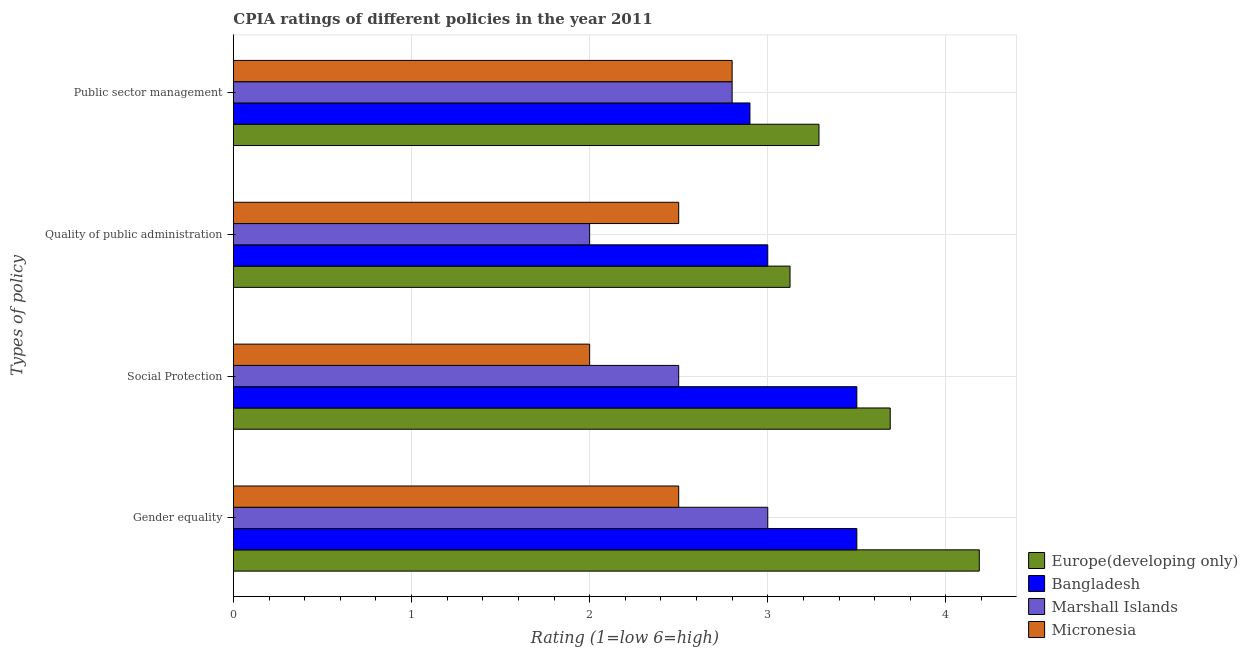Are the number of bars on each tick of the Y-axis equal?
Give a very brief answer. Yes. What is the label of the 2nd group of bars from the top?
Ensure brevity in your answer.  Quality of public administration. Across all countries, what is the maximum cpia rating of social protection?
Make the answer very short. 3.69. Across all countries, what is the minimum cpia rating of gender equality?
Your answer should be compact. 2.5. In which country was the cpia rating of quality of public administration maximum?
Your answer should be very brief. Europe(developing only). In which country was the cpia rating of social protection minimum?
Your answer should be very brief. Micronesia. What is the total cpia rating of quality of public administration in the graph?
Give a very brief answer. 10.62. What is the difference between the cpia rating of social protection in Europe(developing only) and that in Marshall Islands?
Give a very brief answer. 1.19. What is the difference between the cpia rating of social protection in Marshall Islands and the cpia rating of quality of public administration in Europe(developing only)?
Your response must be concise. -0.62. What is the average cpia rating of social protection per country?
Provide a succinct answer. 2.92. What is the difference between the cpia rating of social protection and cpia rating of quality of public administration in Europe(developing only)?
Provide a short and direct response. 0.56. In how many countries, is the cpia rating of social protection greater than 3 ?
Make the answer very short. 2. What is the ratio of the cpia rating of quality of public administration in Bangladesh to that in Europe(developing only)?
Ensure brevity in your answer.  0.96. Is the cpia rating of gender equality in Bangladesh less than that in Micronesia?
Provide a succinct answer. No. What is the difference between the highest and the second highest cpia rating of quality of public administration?
Give a very brief answer. 0.12. In how many countries, is the cpia rating of public sector management greater than the average cpia rating of public sector management taken over all countries?
Keep it short and to the point. 1. Is the sum of the cpia rating of gender equality in Marshall Islands and Micronesia greater than the maximum cpia rating of social protection across all countries?
Provide a succinct answer. Yes. Is it the case that in every country, the sum of the cpia rating of gender equality and cpia rating of social protection is greater than the sum of cpia rating of public sector management and cpia rating of quality of public administration?
Ensure brevity in your answer.  No. What does the 1st bar from the top in Quality of public administration represents?
Offer a very short reply. Micronesia. What does the 3rd bar from the bottom in Social Protection represents?
Make the answer very short. Marshall Islands. How many bars are there?
Provide a short and direct response. 16. How many countries are there in the graph?
Your response must be concise. 4. Are the values on the major ticks of X-axis written in scientific E-notation?
Your answer should be compact. No. Does the graph contain any zero values?
Your answer should be compact. No. Does the graph contain grids?
Make the answer very short. Yes. How are the legend labels stacked?
Offer a terse response. Vertical. What is the title of the graph?
Your answer should be very brief. CPIA ratings of different policies in the year 2011. What is the label or title of the X-axis?
Your response must be concise. Rating (1=low 6=high). What is the label or title of the Y-axis?
Provide a short and direct response. Types of policy. What is the Rating (1=low 6=high) of Europe(developing only) in Gender equality?
Your answer should be very brief. 4.19. What is the Rating (1=low 6=high) of Bangladesh in Gender equality?
Your answer should be very brief. 3.5. What is the Rating (1=low 6=high) in Marshall Islands in Gender equality?
Give a very brief answer. 3. What is the Rating (1=low 6=high) in Europe(developing only) in Social Protection?
Offer a terse response. 3.69. What is the Rating (1=low 6=high) of Bangladesh in Social Protection?
Offer a terse response. 3.5. What is the Rating (1=low 6=high) of Micronesia in Social Protection?
Offer a terse response. 2. What is the Rating (1=low 6=high) in Europe(developing only) in Quality of public administration?
Give a very brief answer. 3.12. What is the Rating (1=low 6=high) in Europe(developing only) in Public sector management?
Ensure brevity in your answer.  3.29. What is the Rating (1=low 6=high) of Bangladesh in Public sector management?
Offer a terse response. 2.9. Across all Types of policy, what is the maximum Rating (1=low 6=high) in Europe(developing only)?
Make the answer very short. 4.19. Across all Types of policy, what is the maximum Rating (1=low 6=high) of Marshall Islands?
Your answer should be compact. 3. Across all Types of policy, what is the minimum Rating (1=low 6=high) in Europe(developing only)?
Provide a succinct answer. 3.12. Across all Types of policy, what is the minimum Rating (1=low 6=high) in Micronesia?
Give a very brief answer. 2. What is the total Rating (1=low 6=high) in Europe(developing only) in the graph?
Offer a very short reply. 14.29. What is the total Rating (1=low 6=high) in Marshall Islands in the graph?
Ensure brevity in your answer.  10.3. What is the total Rating (1=low 6=high) in Micronesia in the graph?
Ensure brevity in your answer.  9.8. What is the difference between the Rating (1=low 6=high) of Europe(developing only) in Gender equality and that in Quality of public administration?
Give a very brief answer. 1.06. What is the difference between the Rating (1=low 6=high) in Bangladesh in Gender equality and that in Quality of public administration?
Ensure brevity in your answer.  0.5. What is the difference between the Rating (1=low 6=high) of Marshall Islands in Gender equality and that in Quality of public administration?
Your answer should be very brief. 1. What is the difference between the Rating (1=low 6=high) in Europe(developing only) in Gender equality and that in Public sector management?
Ensure brevity in your answer.  0.9. What is the difference between the Rating (1=low 6=high) in Marshall Islands in Gender equality and that in Public sector management?
Ensure brevity in your answer.  0.2. What is the difference between the Rating (1=low 6=high) in Micronesia in Gender equality and that in Public sector management?
Offer a very short reply. -0.3. What is the difference between the Rating (1=low 6=high) in Europe(developing only) in Social Protection and that in Quality of public administration?
Your answer should be compact. 0.56. What is the difference between the Rating (1=low 6=high) in Marshall Islands in Social Protection and that in Quality of public administration?
Offer a very short reply. 0.5. What is the difference between the Rating (1=low 6=high) of Marshall Islands in Social Protection and that in Public sector management?
Provide a short and direct response. -0.3. What is the difference between the Rating (1=low 6=high) of Europe(developing only) in Quality of public administration and that in Public sector management?
Ensure brevity in your answer.  -0.16. What is the difference between the Rating (1=low 6=high) of Bangladesh in Quality of public administration and that in Public sector management?
Offer a terse response. 0.1. What is the difference between the Rating (1=low 6=high) of Marshall Islands in Quality of public administration and that in Public sector management?
Give a very brief answer. -0.8. What is the difference between the Rating (1=low 6=high) in Micronesia in Quality of public administration and that in Public sector management?
Offer a terse response. -0.3. What is the difference between the Rating (1=low 6=high) of Europe(developing only) in Gender equality and the Rating (1=low 6=high) of Bangladesh in Social Protection?
Provide a succinct answer. 0.69. What is the difference between the Rating (1=low 6=high) in Europe(developing only) in Gender equality and the Rating (1=low 6=high) in Marshall Islands in Social Protection?
Provide a short and direct response. 1.69. What is the difference between the Rating (1=low 6=high) in Europe(developing only) in Gender equality and the Rating (1=low 6=high) in Micronesia in Social Protection?
Your response must be concise. 2.19. What is the difference between the Rating (1=low 6=high) of Bangladesh in Gender equality and the Rating (1=low 6=high) of Marshall Islands in Social Protection?
Give a very brief answer. 1. What is the difference between the Rating (1=low 6=high) of Bangladesh in Gender equality and the Rating (1=low 6=high) of Micronesia in Social Protection?
Ensure brevity in your answer.  1.5. What is the difference between the Rating (1=low 6=high) in Marshall Islands in Gender equality and the Rating (1=low 6=high) in Micronesia in Social Protection?
Offer a terse response. 1. What is the difference between the Rating (1=low 6=high) in Europe(developing only) in Gender equality and the Rating (1=low 6=high) in Bangladesh in Quality of public administration?
Offer a very short reply. 1.19. What is the difference between the Rating (1=low 6=high) in Europe(developing only) in Gender equality and the Rating (1=low 6=high) in Marshall Islands in Quality of public administration?
Offer a terse response. 2.19. What is the difference between the Rating (1=low 6=high) of Europe(developing only) in Gender equality and the Rating (1=low 6=high) of Micronesia in Quality of public administration?
Give a very brief answer. 1.69. What is the difference between the Rating (1=low 6=high) of Bangladesh in Gender equality and the Rating (1=low 6=high) of Marshall Islands in Quality of public administration?
Ensure brevity in your answer.  1.5. What is the difference between the Rating (1=low 6=high) of Bangladesh in Gender equality and the Rating (1=low 6=high) of Micronesia in Quality of public administration?
Provide a succinct answer. 1. What is the difference between the Rating (1=low 6=high) in Marshall Islands in Gender equality and the Rating (1=low 6=high) in Micronesia in Quality of public administration?
Offer a terse response. 0.5. What is the difference between the Rating (1=low 6=high) of Europe(developing only) in Gender equality and the Rating (1=low 6=high) of Bangladesh in Public sector management?
Your answer should be very brief. 1.29. What is the difference between the Rating (1=low 6=high) of Europe(developing only) in Gender equality and the Rating (1=low 6=high) of Marshall Islands in Public sector management?
Provide a succinct answer. 1.39. What is the difference between the Rating (1=low 6=high) of Europe(developing only) in Gender equality and the Rating (1=low 6=high) of Micronesia in Public sector management?
Your answer should be compact. 1.39. What is the difference between the Rating (1=low 6=high) in Bangladesh in Gender equality and the Rating (1=low 6=high) in Marshall Islands in Public sector management?
Offer a terse response. 0.7. What is the difference between the Rating (1=low 6=high) in Marshall Islands in Gender equality and the Rating (1=low 6=high) in Micronesia in Public sector management?
Your response must be concise. 0.2. What is the difference between the Rating (1=low 6=high) in Europe(developing only) in Social Protection and the Rating (1=low 6=high) in Bangladesh in Quality of public administration?
Provide a short and direct response. 0.69. What is the difference between the Rating (1=low 6=high) of Europe(developing only) in Social Protection and the Rating (1=low 6=high) of Marshall Islands in Quality of public administration?
Ensure brevity in your answer.  1.69. What is the difference between the Rating (1=low 6=high) in Europe(developing only) in Social Protection and the Rating (1=low 6=high) in Micronesia in Quality of public administration?
Your answer should be compact. 1.19. What is the difference between the Rating (1=low 6=high) in Bangladesh in Social Protection and the Rating (1=low 6=high) in Marshall Islands in Quality of public administration?
Your answer should be compact. 1.5. What is the difference between the Rating (1=low 6=high) in Bangladesh in Social Protection and the Rating (1=low 6=high) in Micronesia in Quality of public administration?
Offer a very short reply. 1. What is the difference between the Rating (1=low 6=high) of Marshall Islands in Social Protection and the Rating (1=low 6=high) of Micronesia in Quality of public administration?
Offer a terse response. 0. What is the difference between the Rating (1=low 6=high) of Europe(developing only) in Social Protection and the Rating (1=low 6=high) of Bangladesh in Public sector management?
Your response must be concise. 0.79. What is the difference between the Rating (1=low 6=high) in Europe(developing only) in Social Protection and the Rating (1=low 6=high) in Marshall Islands in Public sector management?
Your answer should be very brief. 0.89. What is the difference between the Rating (1=low 6=high) of Europe(developing only) in Social Protection and the Rating (1=low 6=high) of Micronesia in Public sector management?
Offer a very short reply. 0.89. What is the difference between the Rating (1=low 6=high) of Marshall Islands in Social Protection and the Rating (1=low 6=high) of Micronesia in Public sector management?
Your response must be concise. -0.3. What is the difference between the Rating (1=low 6=high) of Europe(developing only) in Quality of public administration and the Rating (1=low 6=high) of Bangladesh in Public sector management?
Provide a succinct answer. 0.23. What is the difference between the Rating (1=low 6=high) of Europe(developing only) in Quality of public administration and the Rating (1=low 6=high) of Marshall Islands in Public sector management?
Make the answer very short. 0.33. What is the difference between the Rating (1=low 6=high) of Europe(developing only) in Quality of public administration and the Rating (1=low 6=high) of Micronesia in Public sector management?
Make the answer very short. 0.33. What is the difference between the Rating (1=low 6=high) of Bangladesh in Quality of public administration and the Rating (1=low 6=high) of Marshall Islands in Public sector management?
Give a very brief answer. 0.2. What is the difference between the Rating (1=low 6=high) in Bangladesh in Quality of public administration and the Rating (1=low 6=high) in Micronesia in Public sector management?
Give a very brief answer. 0.2. What is the average Rating (1=low 6=high) of Europe(developing only) per Types of policy?
Your response must be concise. 3.57. What is the average Rating (1=low 6=high) in Bangladesh per Types of policy?
Provide a succinct answer. 3.23. What is the average Rating (1=low 6=high) of Marshall Islands per Types of policy?
Keep it short and to the point. 2.58. What is the average Rating (1=low 6=high) of Micronesia per Types of policy?
Offer a very short reply. 2.45. What is the difference between the Rating (1=low 6=high) in Europe(developing only) and Rating (1=low 6=high) in Bangladesh in Gender equality?
Give a very brief answer. 0.69. What is the difference between the Rating (1=low 6=high) in Europe(developing only) and Rating (1=low 6=high) in Marshall Islands in Gender equality?
Offer a very short reply. 1.19. What is the difference between the Rating (1=low 6=high) of Europe(developing only) and Rating (1=low 6=high) of Micronesia in Gender equality?
Provide a short and direct response. 1.69. What is the difference between the Rating (1=low 6=high) in Bangladesh and Rating (1=low 6=high) in Marshall Islands in Gender equality?
Your answer should be very brief. 0.5. What is the difference between the Rating (1=low 6=high) in Marshall Islands and Rating (1=low 6=high) in Micronesia in Gender equality?
Offer a very short reply. 0.5. What is the difference between the Rating (1=low 6=high) in Europe(developing only) and Rating (1=low 6=high) in Bangladesh in Social Protection?
Ensure brevity in your answer.  0.19. What is the difference between the Rating (1=low 6=high) of Europe(developing only) and Rating (1=low 6=high) of Marshall Islands in Social Protection?
Your answer should be very brief. 1.19. What is the difference between the Rating (1=low 6=high) in Europe(developing only) and Rating (1=low 6=high) in Micronesia in Social Protection?
Your response must be concise. 1.69. What is the difference between the Rating (1=low 6=high) in Bangladesh and Rating (1=low 6=high) in Marshall Islands in Social Protection?
Provide a succinct answer. 1. What is the difference between the Rating (1=low 6=high) in Europe(developing only) and Rating (1=low 6=high) in Bangladesh in Quality of public administration?
Make the answer very short. 0.12. What is the difference between the Rating (1=low 6=high) in Europe(developing only) and Rating (1=low 6=high) in Marshall Islands in Quality of public administration?
Offer a very short reply. 1.12. What is the difference between the Rating (1=low 6=high) of Europe(developing only) and Rating (1=low 6=high) of Micronesia in Quality of public administration?
Make the answer very short. 0.62. What is the difference between the Rating (1=low 6=high) of Bangladesh and Rating (1=low 6=high) of Micronesia in Quality of public administration?
Make the answer very short. 0.5. What is the difference between the Rating (1=low 6=high) of Europe(developing only) and Rating (1=low 6=high) of Bangladesh in Public sector management?
Make the answer very short. 0.39. What is the difference between the Rating (1=low 6=high) in Europe(developing only) and Rating (1=low 6=high) in Marshall Islands in Public sector management?
Provide a succinct answer. 0.49. What is the difference between the Rating (1=low 6=high) in Europe(developing only) and Rating (1=low 6=high) in Micronesia in Public sector management?
Keep it short and to the point. 0.49. What is the difference between the Rating (1=low 6=high) of Bangladesh and Rating (1=low 6=high) of Marshall Islands in Public sector management?
Your answer should be very brief. 0.1. What is the difference between the Rating (1=low 6=high) of Bangladesh and Rating (1=low 6=high) of Micronesia in Public sector management?
Offer a terse response. 0.1. What is the ratio of the Rating (1=low 6=high) in Europe(developing only) in Gender equality to that in Social Protection?
Give a very brief answer. 1.14. What is the ratio of the Rating (1=low 6=high) of Bangladesh in Gender equality to that in Social Protection?
Ensure brevity in your answer.  1. What is the ratio of the Rating (1=low 6=high) of Micronesia in Gender equality to that in Social Protection?
Give a very brief answer. 1.25. What is the ratio of the Rating (1=low 6=high) of Europe(developing only) in Gender equality to that in Quality of public administration?
Provide a short and direct response. 1.34. What is the ratio of the Rating (1=low 6=high) in Bangladesh in Gender equality to that in Quality of public administration?
Your answer should be very brief. 1.17. What is the ratio of the Rating (1=low 6=high) in Marshall Islands in Gender equality to that in Quality of public administration?
Provide a short and direct response. 1.5. What is the ratio of the Rating (1=low 6=high) in Micronesia in Gender equality to that in Quality of public administration?
Your answer should be very brief. 1. What is the ratio of the Rating (1=low 6=high) of Europe(developing only) in Gender equality to that in Public sector management?
Your answer should be very brief. 1.27. What is the ratio of the Rating (1=low 6=high) in Bangladesh in Gender equality to that in Public sector management?
Keep it short and to the point. 1.21. What is the ratio of the Rating (1=low 6=high) in Marshall Islands in Gender equality to that in Public sector management?
Your answer should be very brief. 1.07. What is the ratio of the Rating (1=low 6=high) of Micronesia in Gender equality to that in Public sector management?
Offer a very short reply. 0.89. What is the ratio of the Rating (1=low 6=high) of Europe(developing only) in Social Protection to that in Quality of public administration?
Keep it short and to the point. 1.18. What is the ratio of the Rating (1=low 6=high) of Bangladesh in Social Protection to that in Quality of public administration?
Your answer should be very brief. 1.17. What is the ratio of the Rating (1=low 6=high) in Marshall Islands in Social Protection to that in Quality of public administration?
Provide a succinct answer. 1.25. What is the ratio of the Rating (1=low 6=high) of Europe(developing only) in Social Protection to that in Public sector management?
Offer a very short reply. 1.12. What is the ratio of the Rating (1=low 6=high) in Bangladesh in Social Protection to that in Public sector management?
Give a very brief answer. 1.21. What is the ratio of the Rating (1=low 6=high) of Marshall Islands in Social Protection to that in Public sector management?
Your answer should be very brief. 0.89. What is the ratio of the Rating (1=low 6=high) of Micronesia in Social Protection to that in Public sector management?
Your response must be concise. 0.71. What is the ratio of the Rating (1=low 6=high) of Europe(developing only) in Quality of public administration to that in Public sector management?
Give a very brief answer. 0.95. What is the ratio of the Rating (1=low 6=high) of Bangladesh in Quality of public administration to that in Public sector management?
Offer a very short reply. 1.03. What is the ratio of the Rating (1=low 6=high) in Micronesia in Quality of public administration to that in Public sector management?
Make the answer very short. 0.89. What is the difference between the highest and the second highest Rating (1=low 6=high) of Europe(developing only)?
Provide a succinct answer. 0.5. What is the difference between the highest and the second highest Rating (1=low 6=high) of Bangladesh?
Offer a terse response. 0. What is the difference between the highest and the lowest Rating (1=low 6=high) of Marshall Islands?
Provide a succinct answer. 1. 